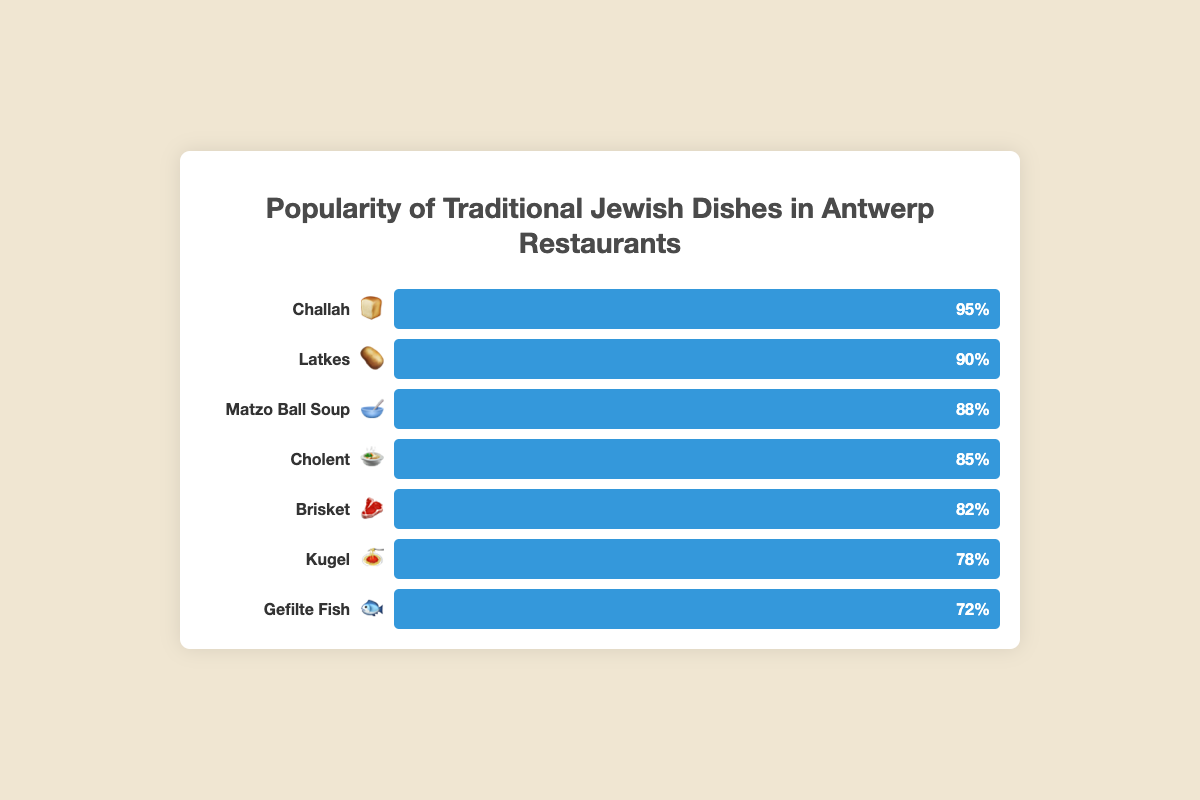What is the title of the chart? The title is usually displayed at the top of the chart. It summarizes the main topic of the chart.
Answer: Popularity of Traditional Jewish Dishes in Antwerp Restaurants Which dish is represented with the emoji 🍞? Look for the dish name next to the emoji 🍞 in the chart.
Answer: Challah What is the popularity percentage of Matzo Ball Soup 🥣? Find the dish Matzo Ball Soup 🥣 in the chart and read its popularity percentage.
Answer: 88% Which dish has the highest popularity? Identify the dish with the highest percentage bar.
Answer: Challah Compare the popularity of Gefilte Fish 🐟 and Brisket 🥩. Which is more popular? Locate both Gefilte Fish 🐟 and Brisket 🥩 in the chart and compare their popularity percentages.
Answer: Brisket How many traditional Jewish dishes have a popularity percentage above 80%? Count the number of dishes with a popularity percentage greater than 80%.
Answer: 5 What's the average popularity of Cholent 🍲, Gefilte Fish 🐟, and Kugel 🍝? Add the popularity percentages of Cholent 🍲 (85), Gefilte Fish 🐟 (72), and Kugel 🍝 (78) and divide by 3.
Answer: 78.3% Which two dishes' popularity sum up to 180%? Identify the dishes whose combined popularity percentages equal to 180%. After checking each, it's Matzo Ball Soup 🥣 (88) and Brisket 🥩 (82).
Answer: Matzo Ball Soup and Brisket Is the popularity of Latkes 🥔 greater than Gefilte Fish 🐟 and Kugel 🍝 combined? Compare Latkes 🥔 (90) with the sum of Gefilte Fish 🐟 (72) and Kugel 🍝 (78). 90 is not greater than 150.
Answer: No 